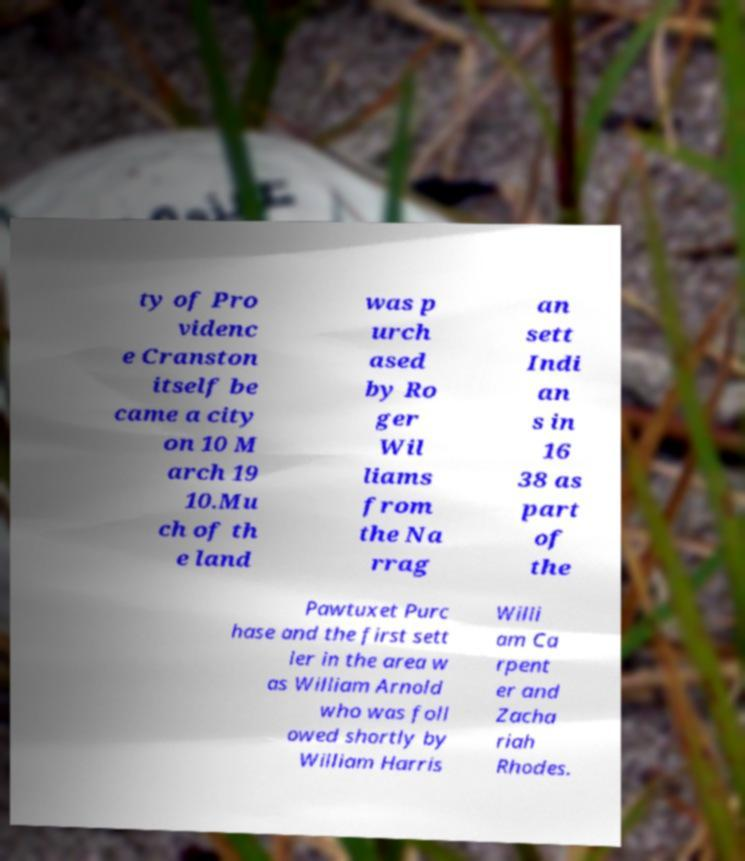Please read and relay the text visible in this image. What does it say? ty of Pro videnc e Cranston itself be came a city on 10 M arch 19 10.Mu ch of th e land was p urch ased by Ro ger Wil liams from the Na rrag an sett Indi an s in 16 38 as part of the Pawtuxet Purc hase and the first sett ler in the area w as William Arnold who was foll owed shortly by William Harris Willi am Ca rpent er and Zacha riah Rhodes. 